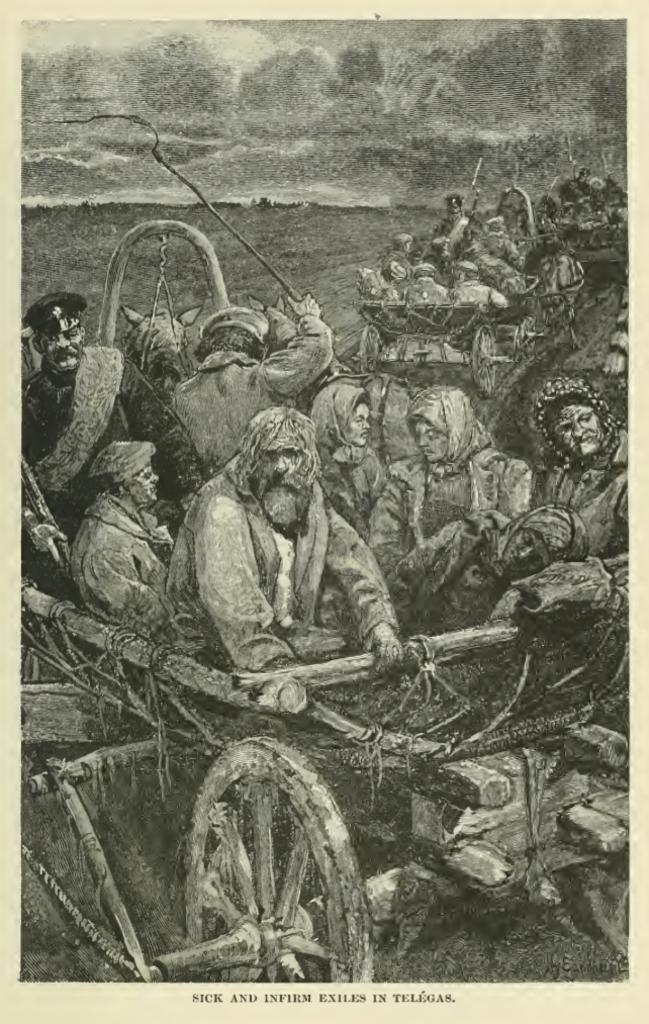What is the main subject of the image? The main subject of the image is a painting. What is depicted in the painting? The painting contains people on carts. Is there any text associated with the painting in the image? Yes, there is text under the painting. How many cats can be seen interacting with the people on the carts in the painting? There are no cats present in the painting; it features people on carts. What type of sorting method is used by the passengers in the painting? There is no indication of any sorting method being used by the passengers in the painting, as it depicts people on carts. 